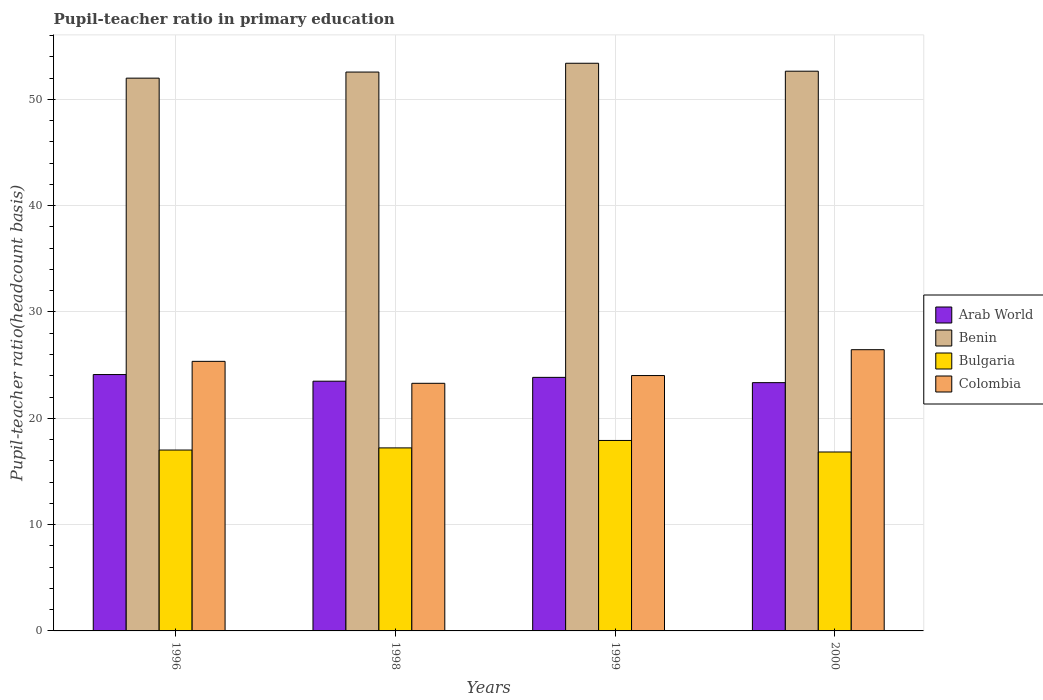How many groups of bars are there?
Offer a terse response. 4. How many bars are there on the 2nd tick from the left?
Provide a short and direct response. 4. What is the label of the 3rd group of bars from the left?
Make the answer very short. 1999. In how many cases, is the number of bars for a given year not equal to the number of legend labels?
Your answer should be very brief. 0. What is the pupil-teacher ratio in primary education in Benin in 1996?
Keep it short and to the point. 52. Across all years, what is the maximum pupil-teacher ratio in primary education in Bulgaria?
Make the answer very short. 17.91. Across all years, what is the minimum pupil-teacher ratio in primary education in Bulgaria?
Give a very brief answer. 16.83. In which year was the pupil-teacher ratio in primary education in Colombia minimum?
Make the answer very short. 1998. What is the total pupil-teacher ratio in primary education in Colombia in the graph?
Your response must be concise. 99.12. What is the difference between the pupil-teacher ratio in primary education in Bulgaria in 1996 and that in 1998?
Ensure brevity in your answer.  -0.2. What is the difference between the pupil-teacher ratio in primary education in Colombia in 2000 and the pupil-teacher ratio in primary education in Bulgaria in 1999?
Offer a terse response. 8.54. What is the average pupil-teacher ratio in primary education in Bulgaria per year?
Provide a short and direct response. 17.24. In the year 1998, what is the difference between the pupil-teacher ratio in primary education in Arab World and pupil-teacher ratio in primary education in Benin?
Your answer should be compact. -29.08. What is the ratio of the pupil-teacher ratio in primary education in Benin in 1996 to that in 1998?
Keep it short and to the point. 0.99. What is the difference between the highest and the second highest pupil-teacher ratio in primary education in Arab World?
Make the answer very short. 0.26. What is the difference between the highest and the lowest pupil-teacher ratio in primary education in Colombia?
Your answer should be compact. 3.16. What does the 2nd bar from the left in 2000 represents?
Provide a short and direct response. Benin. What does the 2nd bar from the right in 1998 represents?
Provide a short and direct response. Bulgaria. How many bars are there?
Your answer should be very brief. 16. Does the graph contain any zero values?
Your response must be concise. No. Where does the legend appear in the graph?
Your answer should be very brief. Center right. How are the legend labels stacked?
Your response must be concise. Vertical. What is the title of the graph?
Offer a very short reply. Pupil-teacher ratio in primary education. Does "Isle of Man" appear as one of the legend labels in the graph?
Offer a terse response. No. What is the label or title of the Y-axis?
Offer a terse response. Pupil-teacher ratio(headcount basis). What is the Pupil-teacher ratio(headcount basis) in Arab World in 1996?
Offer a terse response. 24.11. What is the Pupil-teacher ratio(headcount basis) of Benin in 1996?
Provide a short and direct response. 52. What is the Pupil-teacher ratio(headcount basis) of Bulgaria in 1996?
Provide a succinct answer. 17.01. What is the Pupil-teacher ratio(headcount basis) in Colombia in 1996?
Make the answer very short. 25.36. What is the Pupil-teacher ratio(headcount basis) in Arab World in 1998?
Your response must be concise. 23.49. What is the Pupil-teacher ratio(headcount basis) in Benin in 1998?
Your answer should be very brief. 52.57. What is the Pupil-teacher ratio(headcount basis) in Bulgaria in 1998?
Provide a short and direct response. 17.22. What is the Pupil-teacher ratio(headcount basis) of Colombia in 1998?
Give a very brief answer. 23.29. What is the Pupil-teacher ratio(headcount basis) in Arab World in 1999?
Your answer should be very brief. 23.85. What is the Pupil-teacher ratio(headcount basis) of Benin in 1999?
Offer a very short reply. 53.4. What is the Pupil-teacher ratio(headcount basis) in Bulgaria in 1999?
Provide a short and direct response. 17.91. What is the Pupil-teacher ratio(headcount basis) in Colombia in 1999?
Keep it short and to the point. 24.02. What is the Pupil-teacher ratio(headcount basis) of Arab World in 2000?
Ensure brevity in your answer.  23.35. What is the Pupil-teacher ratio(headcount basis) of Benin in 2000?
Your answer should be very brief. 52.65. What is the Pupil-teacher ratio(headcount basis) in Bulgaria in 2000?
Your answer should be compact. 16.83. What is the Pupil-teacher ratio(headcount basis) in Colombia in 2000?
Ensure brevity in your answer.  26.45. Across all years, what is the maximum Pupil-teacher ratio(headcount basis) in Arab World?
Your response must be concise. 24.11. Across all years, what is the maximum Pupil-teacher ratio(headcount basis) of Benin?
Make the answer very short. 53.4. Across all years, what is the maximum Pupil-teacher ratio(headcount basis) of Bulgaria?
Offer a terse response. 17.91. Across all years, what is the maximum Pupil-teacher ratio(headcount basis) of Colombia?
Your response must be concise. 26.45. Across all years, what is the minimum Pupil-teacher ratio(headcount basis) of Arab World?
Your answer should be compact. 23.35. Across all years, what is the minimum Pupil-teacher ratio(headcount basis) of Benin?
Keep it short and to the point. 52. Across all years, what is the minimum Pupil-teacher ratio(headcount basis) in Bulgaria?
Give a very brief answer. 16.83. Across all years, what is the minimum Pupil-teacher ratio(headcount basis) of Colombia?
Your answer should be compact. 23.29. What is the total Pupil-teacher ratio(headcount basis) in Arab World in the graph?
Your answer should be very brief. 94.81. What is the total Pupil-teacher ratio(headcount basis) of Benin in the graph?
Your answer should be very brief. 210.61. What is the total Pupil-teacher ratio(headcount basis) in Bulgaria in the graph?
Give a very brief answer. 68.97. What is the total Pupil-teacher ratio(headcount basis) of Colombia in the graph?
Provide a succinct answer. 99.12. What is the difference between the Pupil-teacher ratio(headcount basis) of Arab World in 1996 and that in 1998?
Provide a short and direct response. 0.62. What is the difference between the Pupil-teacher ratio(headcount basis) of Benin in 1996 and that in 1998?
Provide a short and direct response. -0.57. What is the difference between the Pupil-teacher ratio(headcount basis) in Bulgaria in 1996 and that in 1998?
Provide a short and direct response. -0.2. What is the difference between the Pupil-teacher ratio(headcount basis) in Colombia in 1996 and that in 1998?
Your response must be concise. 2.06. What is the difference between the Pupil-teacher ratio(headcount basis) of Arab World in 1996 and that in 1999?
Make the answer very short. 0.26. What is the difference between the Pupil-teacher ratio(headcount basis) in Benin in 1996 and that in 1999?
Offer a terse response. -1.4. What is the difference between the Pupil-teacher ratio(headcount basis) in Bulgaria in 1996 and that in 1999?
Your response must be concise. -0.9. What is the difference between the Pupil-teacher ratio(headcount basis) in Colombia in 1996 and that in 1999?
Provide a short and direct response. 1.34. What is the difference between the Pupil-teacher ratio(headcount basis) in Arab World in 1996 and that in 2000?
Make the answer very short. 0.76. What is the difference between the Pupil-teacher ratio(headcount basis) of Benin in 1996 and that in 2000?
Offer a very short reply. -0.65. What is the difference between the Pupil-teacher ratio(headcount basis) of Bulgaria in 1996 and that in 2000?
Give a very brief answer. 0.18. What is the difference between the Pupil-teacher ratio(headcount basis) in Colombia in 1996 and that in 2000?
Offer a terse response. -1.1. What is the difference between the Pupil-teacher ratio(headcount basis) of Arab World in 1998 and that in 1999?
Your answer should be compact. -0.36. What is the difference between the Pupil-teacher ratio(headcount basis) in Benin in 1998 and that in 1999?
Give a very brief answer. -0.83. What is the difference between the Pupil-teacher ratio(headcount basis) in Bulgaria in 1998 and that in 1999?
Ensure brevity in your answer.  -0.7. What is the difference between the Pupil-teacher ratio(headcount basis) in Colombia in 1998 and that in 1999?
Your answer should be very brief. -0.73. What is the difference between the Pupil-teacher ratio(headcount basis) in Arab World in 1998 and that in 2000?
Make the answer very short. 0.14. What is the difference between the Pupil-teacher ratio(headcount basis) of Benin in 1998 and that in 2000?
Keep it short and to the point. -0.08. What is the difference between the Pupil-teacher ratio(headcount basis) of Bulgaria in 1998 and that in 2000?
Your answer should be compact. 0.39. What is the difference between the Pupil-teacher ratio(headcount basis) of Colombia in 1998 and that in 2000?
Keep it short and to the point. -3.16. What is the difference between the Pupil-teacher ratio(headcount basis) of Arab World in 1999 and that in 2000?
Provide a short and direct response. 0.5. What is the difference between the Pupil-teacher ratio(headcount basis) of Benin in 1999 and that in 2000?
Ensure brevity in your answer.  0.75. What is the difference between the Pupil-teacher ratio(headcount basis) of Bulgaria in 1999 and that in 2000?
Keep it short and to the point. 1.08. What is the difference between the Pupil-teacher ratio(headcount basis) in Colombia in 1999 and that in 2000?
Keep it short and to the point. -2.43. What is the difference between the Pupil-teacher ratio(headcount basis) in Arab World in 1996 and the Pupil-teacher ratio(headcount basis) in Benin in 1998?
Make the answer very short. -28.45. What is the difference between the Pupil-teacher ratio(headcount basis) of Arab World in 1996 and the Pupil-teacher ratio(headcount basis) of Bulgaria in 1998?
Your response must be concise. 6.9. What is the difference between the Pupil-teacher ratio(headcount basis) of Arab World in 1996 and the Pupil-teacher ratio(headcount basis) of Colombia in 1998?
Your response must be concise. 0.82. What is the difference between the Pupil-teacher ratio(headcount basis) in Benin in 1996 and the Pupil-teacher ratio(headcount basis) in Bulgaria in 1998?
Your answer should be very brief. 34.78. What is the difference between the Pupil-teacher ratio(headcount basis) in Benin in 1996 and the Pupil-teacher ratio(headcount basis) in Colombia in 1998?
Your response must be concise. 28.7. What is the difference between the Pupil-teacher ratio(headcount basis) of Bulgaria in 1996 and the Pupil-teacher ratio(headcount basis) of Colombia in 1998?
Your answer should be compact. -6.28. What is the difference between the Pupil-teacher ratio(headcount basis) of Arab World in 1996 and the Pupil-teacher ratio(headcount basis) of Benin in 1999?
Offer a very short reply. -29.28. What is the difference between the Pupil-teacher ratio(headcount basis) in Arab World in 1996 and the Pupil-teacher ratio(headcount basis) in Bulgaria in 1999?
Your answer should be compact. 6.2. What is the difference between the Pupil-teacher ratio(headcount basis) of Arab World in 1996 and the Pupil-teacher ratio(headcount basis) of Colombia in 1999?
Your answer should be very brief. 0.09. What is the difference between the Pupil-teacher ratio(headcount basis) of Benin in 1996 and the Pupil-teacher ratio(headcount basis) of Bulgaria in 1999?
Your response must be concise. 34.08. What is the difference between the Pupil-teacher ratio(headcount basis) of Benin in 1996 and the Pupil-teacher ratio(headcount basis) of Colombia in 1999?
Your answer should be very brief. 27.97. What is the difference between the Pupil-teacher ratio(headcount basis) of Bulgaria in 1996 and the Pupil-teacher ratio(headcount basis) of Colombia in 1999?
Your answer should be very brief. -7.01. What is the difference between the Pupil-teacher ratio(headcount basis) in Arab World in 1996 and the Pupil-teacher ratio(headcount basis) in Benin in 2000?
Provide a succinct answer. -28.53. What is the difference between the Pupil-teacher ratio(headcount basis) in Arab World in 1996 and the Pupil-teacher ratio(headcount basis) in Bulgaria in 2000?
Make the answer very short. 7.29. What is the difference between the Pupil-teacher ratio(headcount basis) in Arab World in 1996 and the Pupil-teacher ratio(headcount basis) in Colombia in 2000?
Keep it short and to the point. -2.34. What is the difference between the Pupil-teacher ratio(headcount basis) of Benin in 1996 and the Pupil-teacher ratio(headcount basis) of Bulgaria in 2000?
Offer a terse response. 35.17. What is the difference between the Pupil-teacher ratio(headcount basis) in Benin in 1996 and the Pupil-teacher ratio(headcount basis) in Colombia in 2000?
Offer a very short reply. 25.54. What is the difference between the Pupil-teacher ratio(headcount basis) of Bulgaria in 1996 and the Pupil-teacher ratio(headcount basis) of Colombia in 2000?
Make the answer very short. -9.44. What is the difference between the Pupil-teacher ratio(headcount basis) of Arab World in 1998 and the Pupil-teacher ratio(headcount basis) of Benin in 1999?
Provide a short and direct response. -29.91. What is the difference between the Pupil-teacher ratio(headcount basis) of Arab World in 1998 and the Pupil-teacher ratio(headcount basis) of Bulgaria in 1999?
Provide a succinct answer. 5.58. What is the difference between the Pupil-teacher ratio(headcount basis) of Arab World in 1998 and the Pupil-teacher ratio(headcount basis) of Colombia in 1999?
Your response must be concise. -0.53. What is the difference between the Pupil-teacher ratio(headcount basis) in Benin in 1998 and the Pupil-teacher ratio(headcount basis) in Bulgaria in 1999?
Keep it short and to the point. 34.65. What is the difference between the Pupil-teacher ratio(headcount basis) in Benin in 1998 and the Pupil-teacher ratio(headcount basis) in Colombia in 1999?
Your answer should be very brief. 28.55. What is the difference between the Pupil-teacher ratio(headcount basis) in Bulgaria in 1998 and the Pupil-teacher ratio(headcount basis) in Colombia in 1999?
Provide a short and direct response. -6.8. What is the difference between the Pupil-teacher ratio(headcount basis) of Arab World in 1998 and the Pupil-teacher ratio(headcount basis) of Benin in 2000?
Offer a very short reply. -29.16. What is the difference between the Pupil-teacher ratio(headcount basis) in Arab World in 1998 and the Pupil-teacher ratio(headcount basis) in Bulgaria in 2000?
Your answer should be very brief. 6.66. What is the difference between the Pupil-teacher ratio(headcount basis) in Arab World in 1998 and the Pupil-teacher ratio(headcount basis) in Colombia in 2000?
Offer a terse response. -2.96. What is the difference between the Pupil-teacher ratio(headcount basis) in Benin in 1998 and the Pupil-teacher ratio(headcount basis) in Bulgaria in 2000?
Offer a terse response. 35.74. What is the difference between the Pupil-teacher ratio(headcount basis) of Benin in 1998 and the Pupil-teacher ratio(headcount basis) of Colombia in 2000?
Provide a succinct answer. 26.12. What is the difference between the Pupil-teacher ratio(headcount basis) of Bulgaria in 1998 and the Pupil-teacher ratio(headcount basis) of Colombia in 2000?
Offer a very short reply. -9.24. What is the difference between the Pupil-teacher ratio(headcount basis) of Arab World in 1999 and the Pupil-teacher ratio(headcount basis) of Benin in 2000?
Ensure brevity in your answer.  -28.8. What is the difference between the Pupil-teacher ratio(headcount basis) in Arab World in 1999 and the Pupil-teacher ratio(headcount basis) in Bulgaria in 2000?
Ensure brevity in your answer.  7.02. What is the difference between the Pupil-teacher ratio(headcount basis) of Arab World in 1999 and the Pupil-teacher ratio(headcount basis) of Colombia in 2000?
Your answer should be very brief. -2.6. What is the difference between the Pupil-teacher ratio(headcount basis) in Benin in 1999 and the Pupil-teacher ratio(headcount basis) in Bulgaria in 2000?
Provide a succinct answer. 36.57. What is the difference between the Pupil-teacher ratio(headcount basis) in Benin in 1999 and the Pupil-teacher ratio(headcount basis) in Colombia in 2000?
Provide a short and direct response. 26.94. What is the difference between the Pupil-teacher ratio(headcount basis) in Bulgaria in 1999 and the Pupil-teacher ratio(headcount basis) in Colombia in 2000?
Your answer should be very brief. -8.54. What is the average Pupil-teacher ratio(headcount basis) of Arab World per year?
Your answer should be compact. 23.7. What is the average Pupil-teacher ratio(headcount basis) in Benin per year?
Provide a succinct answer. 52.65. What is the average Pupil-teacher ratio(headcount basis) of Bulgaria per year?
Your answer should be very brief. 17.24. What is the average Pupil-teacher ratio(headcount basis) of Colombia per year?
Give a very brief answer. 24.78. In the year 1996, what is the difference between the Pupil-teacher ratio(headcount basis) in Arab World and Pupil-teacher ratio(headcount basis) in Benin?
Make the answer very short. -27.88. In the year 1996, what is the difference between the Pupil-teacher ratio(headcount basis) in Arab World and Pupil-teacher ratio(headcount basis) in Bulgaria?
Provide a short and direct response. 7.1. In the year 1996, what is the difference between the Pupil-teacher ratio(headcount basis) in Arab World and Pupil-teacher ratio(headcount basis) in Colombia?
Your answer should be compact. -1.24. In the year 1996, what is the difference between the Pupil-teacher ratio(headcount basis) of Benin and Pupil-teacher ratio(headcount basis) of Bulgaria?
Provide a succinct answer. 34.98. In the year 1996, what is the difference between the Pupil-teacher ratio(headcount basis) in Benin and Pupil-teacher ratio(headcount basis) in Colombia?
Give a very brief answer. 26.64. In the year 1996, what is the difference between the Pupil-teacher ratio(headcount basis) of Bulgaria and Pupil-teacher ratio(headcount basis) of Colombia?
Make the answer very short. -8.34. In the year 1998, what is the difference between the Pupil-teacher ratio(headcount basis) of Arab World and Pupil-teacher ratio(headcount basis) of Benin?
Make the answer very short. -29.08. In the year 1998, what is the difference between the Pupil-teacher ratio(headcount basis) of Arab World and Pupil-teacher ratio(headcount basis) of Bulgaria?
Your answer should be very brief. 6.27. In the year 1998, what is the difference between the Pupil-teacher ratio(headcount basis) in Arab World and Pupil-teacher ratio(headcount basis) in Colombia?
Offer a terse response. 0.2. In the year 1998, what is the difference between the Pupil-teacher ratio(headcount basis) of Benin and Pupil-teacher ratio(headcount basis) of Bulgaria?
Offer a very short reply. 35.35. In the year 1998, what is the difference between the Pupil-teacher ratio(headcount basis) in Benin and Pupil-teacher ratio(headcount basis) in Colombia?
Your answer should be compact. 29.28. In the year 1998, what is the difference between the Pupil-teacher ratio(headcount basis) of Bulgaria and Pupil-teacher ratio(headcount basis) of Colombia?
Make the answer very short. -6.08. In the year 1999, what is the difference between the Pupil-teacher ratio(headcount basis) of Arab World and Pupil-teacher ratio(headcount basis) of Benin?
Offer a very short reply. -29.55. In the year 1999, what is the difference between the Pupil-teacher ratio(headcount basis) of Arab World and Pupil-teacher ratio(headcount basis) of Bulgaria?
Make the answer very short. 5.94. In the year 1999, what is the difference between the Pupil-teacher ratio(headcount basis) of Arab World and Pupil-teacher ratio(headcount basis) of Colombia?
Provide a short and direct response. -0.17. In the year 1999, what is the difference between the Pupil-teacher ratio(headcount basis) in Benin and Pupil-teacher ratio(headcount basis) in Bulgaria?
Your response must be concise. 35.48. In the year 1999, what is the difference between the Pupil-teacher ratio(headcount basis) of Benin and Pupil-teacher ratio(headcount basis) of Colombia?
Offer a very short reply. 29.38. In the year 1999, what is the difference between the Pupil-teacher ratio(headcount basis) of Bulgaria and Pupil-teacher ratio(headcount basis) of Colombia?
Offer a very short reply. -6.11. In the year 2000, what is the difference between the Pupil-teacher ratio(headcount basis) in Arab World and Pupil-teacher ratio(headcount basis) in Benin?
Offer a terse response. -29.3. In the year 2000, what is the difference between the Pupil-teacher ratio(headcount basis) of Arab World and Pupil-teacher ratio(headcount basis) of Bulgaria?
Make the answer very short. 6.52. In the year 2000, what is the difference between the Pupil-teacher ratio(headcount basis) in Arab World and Pupil-teacher ratio(headcount basis) in Colombia?
Make the answer very short. -3.1. In the year 2000, what is the difference between the Pupil-teacher ratio(headcount basis) of Benin and Pupil-teacher ratio(headcount basis) of Bulgaria?
Your answer should be compact. 35.82. In the year 2000, what is the difference between the Pupil-teacher ratio(headcount basis) in Benin and Pupil-teacher ratio(headcount basis) in Colombia?
Your answer should be very brief. 26.2. In the year 2000, what is the difference between the Pupil-teacher ratio(headcount basis) of Bulgaria and Pupil-teacher ratio(headcount basis) of Colombia?
Your response must be concise. -9.62. What is the ratio of the Pupil-teacher ratio(headcount basis) of Arab World in 1996 to that in 1998?
Your response must be concise. 1.03. What is the ratio of the Pupil-teacher ratio(headcount basis) of Bulgaria in 1996 to that in 1998?
Offer a terse response. 0.99. What is the ratio of the Pupil-teacher ratio(headcount basis) of Colombia in 1996 to that in 1998?
Ensure brevity in your answer.  1.09. What is the ratio of the Pupil-teacher ratio(headcount basis) in Arab World in 1996 to that in 1999?
Ensure brevity in your answer.  1.01. What is the ratio of the Pupil-teacher ratio(headcount basis) in Benin in 1996 to that in 1999?
Give a very brief answer. 0.97. What is the ratio of the Pupil-teacher ratio(headcount basis) of Bulgaria in 1996 to that in 1999?
Keep it short and to the point. 0.95. What is the ratio of the Pupil-teacher ratio(headcount basis) of Colombia in 1996 to that in 1999?
Your response must be concise. 1.06. What is the ratio of the Pupil-teacher ratio(headcount basis) of Arab World in 1996 to that in 2000?
Ensure brevity in your answer.  1.03. What is the ratio of the Pupil-teacher ratio(headcount basis) of Benin in 1996 to that in 2000?
Offer a very short reply. 0.99. What is the ratio of the Pupil-teacher ratio(headcount basis) in Bulgaria in 1996 to that in 2000?
Offer a very short reply. 1.01. What is the ratio of the Pupil-teacher ratio(headcount basis) of Colombia in 1996 to that in 2000?
Your answer should be very brief. 0.96. What is the ratio of the Pupil-teacher ratio(headcount basis) in Arab World in 1998 to that in 1999?
Ensure brevity in your answer.  0.98. What is the ratio of the Pupil-teacher ratio(headcount basis) in Benin in 1998 to that in 1999?
Keep it short and to the point. 0.98. What is the ratio of the Pupil-teacher ratio(headcount basis) in Bulgaria in 1998 to that in 1999?
Your answer should be compact. 0.96. What is the ratio of the Pupil-teacher ratio(headcount basis) in Colombia in 1998 to that in 1999?
Your answer should be compact. 0.97. What is the ratio of the Pupil-teacher ratio(headcount basis) in Arab World in 1998 to that in 2000?
Ensure brevity in your answer.  1.01. What is the ratio of the Pupil-teacher ratio(headcount basis) of Bulgaria in 1998 to that in 2000?
Your answer should be compact. 1.02. What is the ratio of the Pupil-teacher ratio(headcount basis) in Colombia in 1998 to that in 2000?
Your answer should be compact. 0.88. What is the ratio of the Pupil-teacher ratio(headcount basis) in Arab World in 1999 to that in 2000?
Provide a succinct answer. 1.02. What is the ratio of the Pupil-teacher ratio(headcount basis) in Benin in 1999 to that in 2000?
Give a very brief answer. 1.01. What is the ratio of the Pupil-teacher ratio(headcount basis) of Bulgaria in 1999 to that in 2000?
Make the answer very short. 1.06. What is the ratio of the Pupil-teacher ratio(headcount basis) in Colombia in 1999 to that in 2000?
Your answer should be very brief. 0.91. What is the difference between the highest and the second highest Pupil-teacher ratio(headcount basis) of Arab World?
Offer a terse response. 0.26. What is the difference between the highest and the second highest Pupil-teacher ratio(headcount basis) of Benin?
Offer a very short reply. 0.75. What is the difference between the highest and the second highest Pupil-teacher ratio(headcount basis) in Bulgaria?
Ensure brevity in your answer.  0.7. What is the difference between the highest and the second highest Pupil-teacher ratio(headcount basis) in Colombia?
Offer a terse response. 1.1. What is the difference between the highest and the lowest Pupil-teacher ratio(headcount basis) of Arab World?
Provide a short and direct response. 0.76. What is the difference between the highest and the lowest Pupil-teacher ratio(headcount basis) in Benin?
Offer a terse response. 1.4. What is the difference between the highest and the lowest Pupil-teacher ratio(headcount basis) of Bulgaria?
Offer a terse response. 1.08. What is the difference between the highest and the lowest Pupil-teacher ratio(headcount basis) in Colombia?
Offer a terse response. 3.16. 